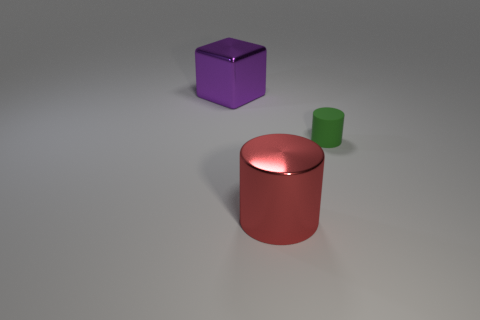Add 2 red shiny spheres. How many objects exist? 5 Subtract all cubes. How many objects are left? 2 Add 2 large purple cubes. How many large purple cubes are left? 3 Add 2 big red metallic cylinders. How many big red metallic cylinders exist? 3 Subtract 0 brown cylinders. How many objects are left? 3 Subtract all red cylinders. Subtract all large yellow blocks. How many objects are left? 2 